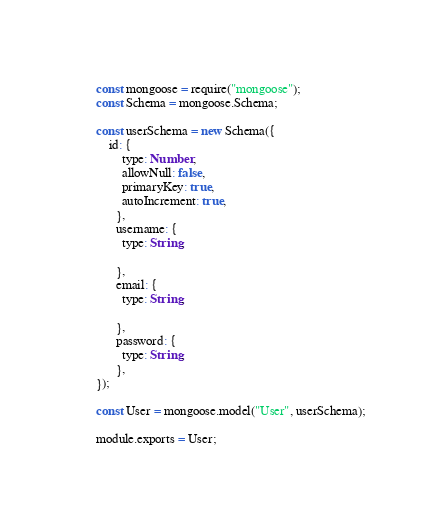<code> <loc_0><loc_0><loc_500><loc_500><_JavaScript_>const mongoose = require("mongoose");
const Schema = mongoose.Schema;

const userSchema = new Schema({
    id: {
        type: Number,
        allowNull: false,
        primaryKey: true,
        autoIncrement: true,
      },
      username: {
        type: String,

      },
      email: {
        type: String,

      },
      password: {
        type: String,
      },
});

const User = mongoose.model("User", userSchema);

module.exports = User;</code> 